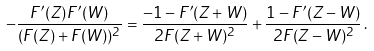Convert formula to latex. <formula><loc_0><loc_0><loc_500><loc_500>- \frac { F ^ { \prime } ( Z ) F ^ { \prime } ( W ) } { ( F ( Z ) + F ( W ) ) ^ { 2 } } = \frac { - 1 - F ^ { \prime } ( Z + W ) } { 2 F ( Z + W ) ^ { 2 } } + \frac { 1 - F ^ { \prime } ( Z - W ) } { 2 F ( Z - W ) ^ { 2 } } \, .</formula> 